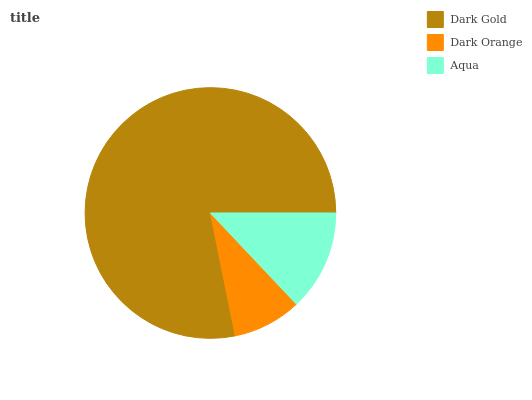Is Dark Orange the minimum?
Answer yes or no. Yes. Is Dark Gold the maximum?
Answer yes or no. Yes. Is Aqua the minimum?
Answer yes or no. No. Is Aqua the maximum?
Answer yes or no. No. Is Aqua greater than Dark Orange?
Answer yes or no. Yes. Is Dark Orange less than Aqua?
Answer yes or no. Yes. Is Dark Orange greater than Aqua?
Answer yes or no. No. Is Aqua less than Dark Orange?
Answer yes or no. No. Is Aqua the high median?
Answer yes or no. Yes. Is Aqua the low median?
Answer yes or no. Yes. Is Dark Orange the high median?
Answer yes or no. No. Is Dark Gold the low median?
Answer yes or no. No. 